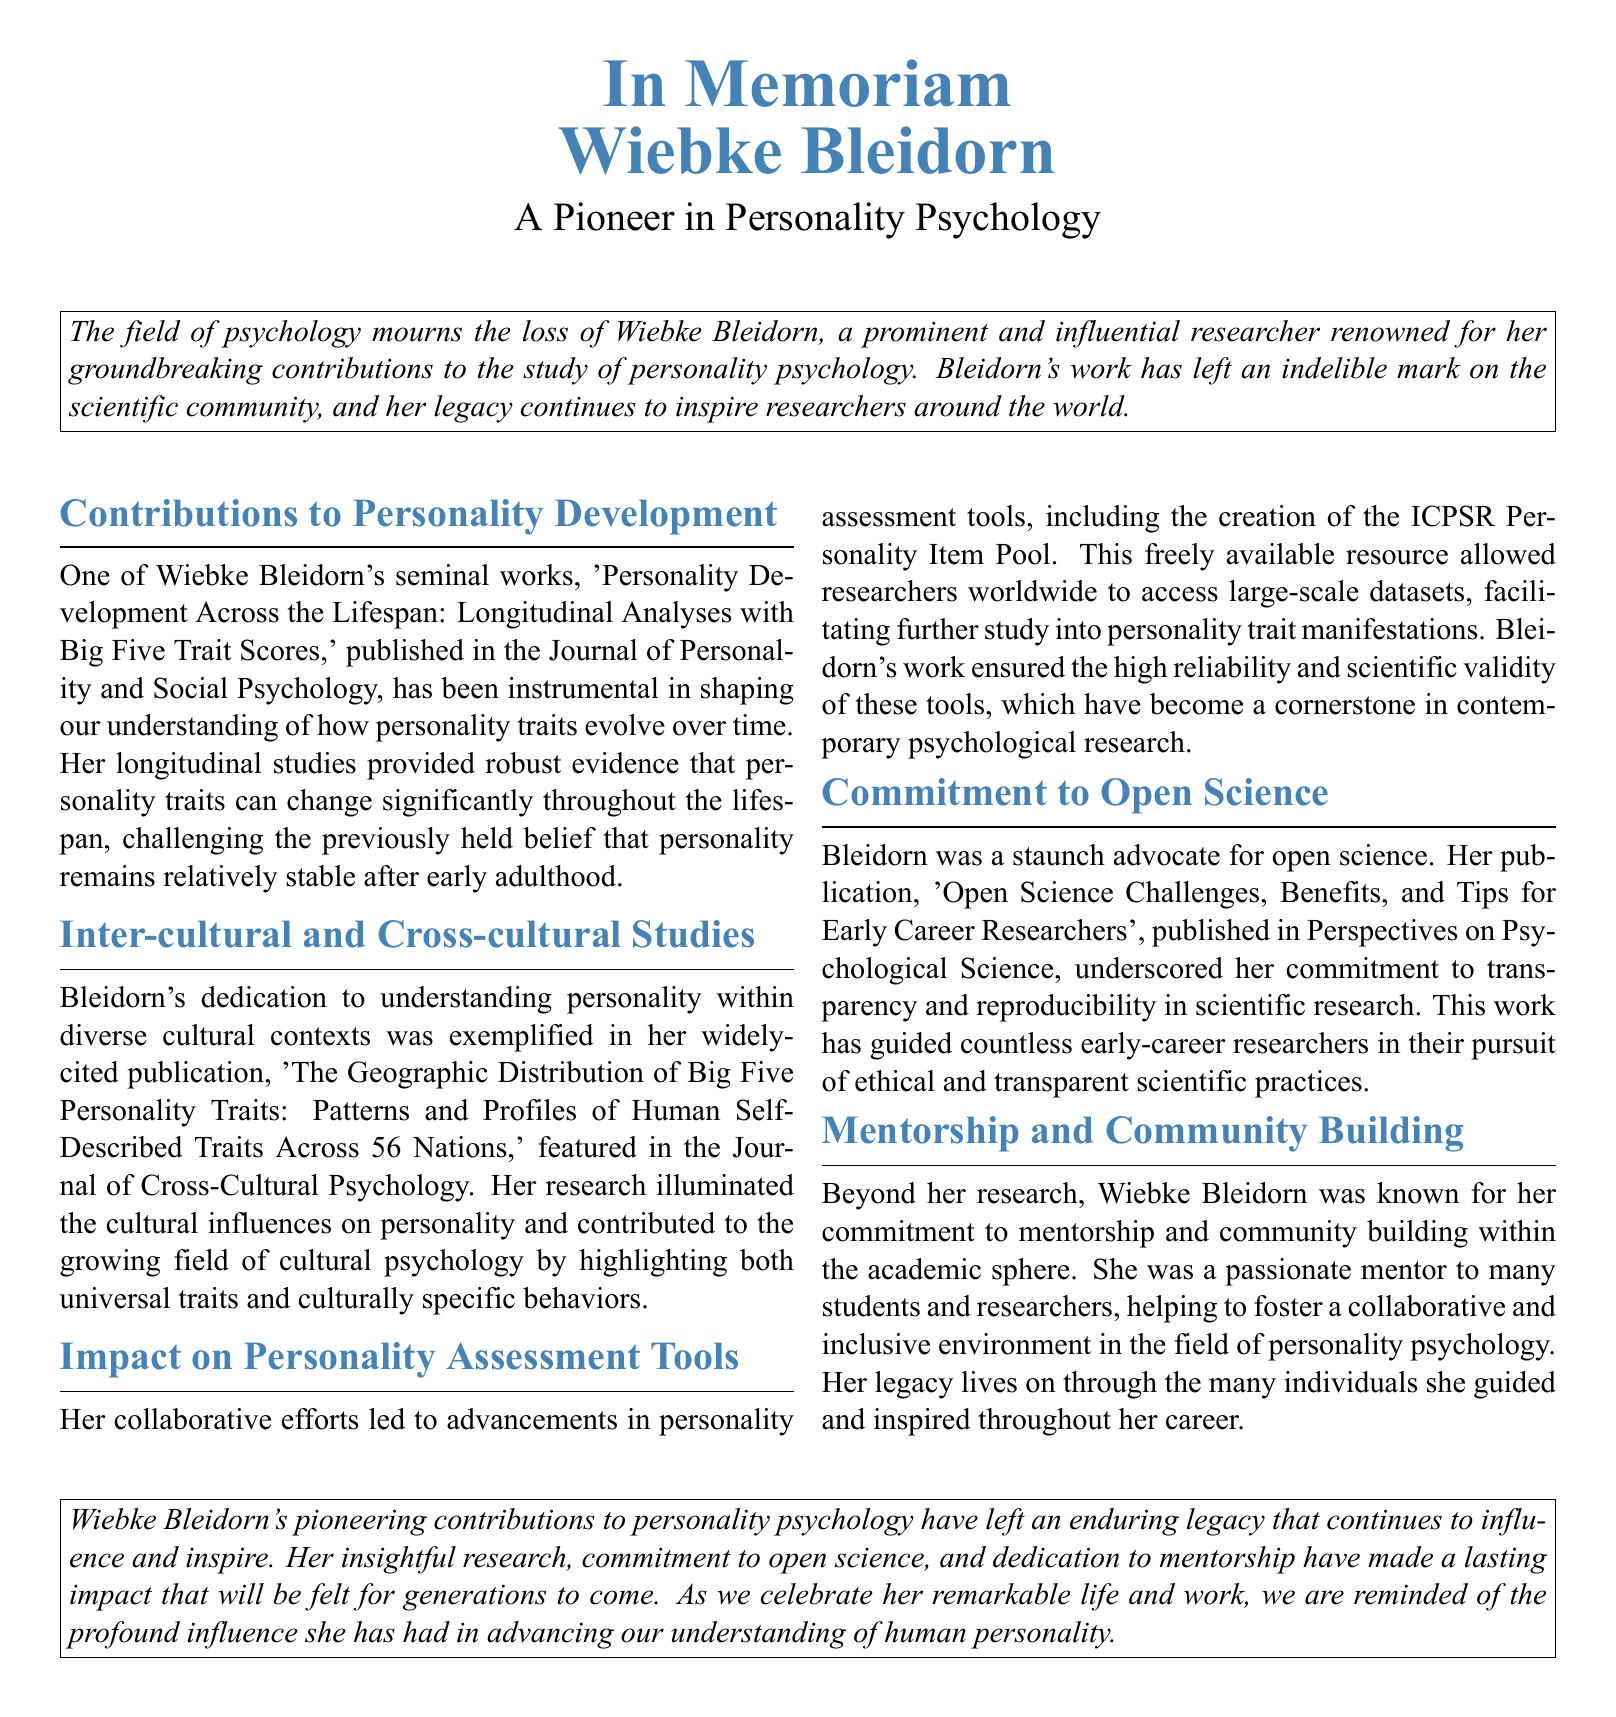What is Wiebke Bleidorn known for? Wiebke Bleidorn is renowned for her groundbreaking contributions to the study of personality psychology.
Answer: personality psychology What is the title of her seminal work on personality development? The title of her seminal work is 'Personality Development Across the Lifespan: Longitudinal Analyses with Big Five Trait Scores.'
Answer: Personality Development Across the Lifespan In which journal was her work on personality development published? Her work was published in the Journal of Personality and Social Psychology.
Answer: Journal of Personality and Social Psychology How many nations did her cross-cultural study analyze? Her study analyzed personality traits across 56 nations.
Answer: 56 What did Bleidorn advocate for in her publication about research practices? She advocated for transparency and reproducibility in scientific research.
Answer: open science What resource did Bleidorn help create for researchers? She helped create the ICPSR Personality Item Pool.
Answer: ICPSR Personality Item Pool What was a key aspect of Bleidorn's mentorship? She helped foster a collaborative and inclusive environment.
Answer: collaborative and inclusive environment Which article focused on challenges for early career researchers? The article is 'Open Science Challenges, Benefits, and Tips for Early Career Researchers.'
Answer: Open Science Challenges, Benefits, and Tips for Early Career Researchers What legacy did Bleidorn leave in personality psychology? She left an enduring legacy that continues to influence and inspire.
Answer: enduring legacy 